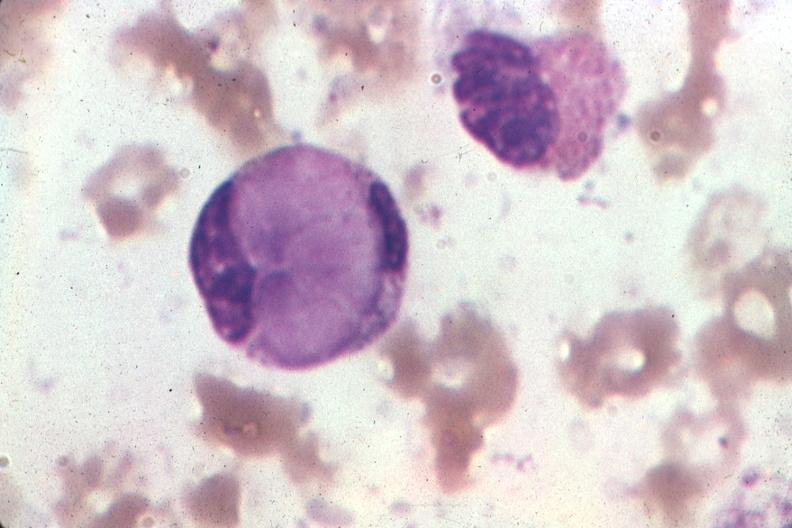s le cell present?
Answer the question using a single word or phrase. Yes 